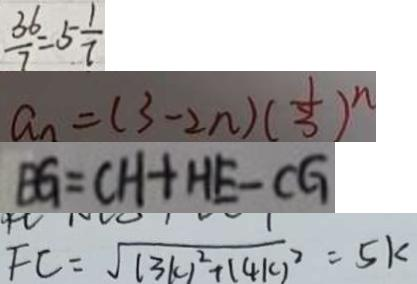<formula> <loc_0><loc_0><loc_500><loc_500>\frac { 3 6 } { 7 } = 5 \frac { 1 } { 7 } 
 a _ { n } = ( 3 - 2 n ) ( \frac { 1 } { 3 } ) ^ { n } 
 B G = C H + H E - C G 
 F C = \sqrt { ( 3 k ) ^ { 2 } + ( 4 k ) ^ { 2 } } = 5 k</formula> 